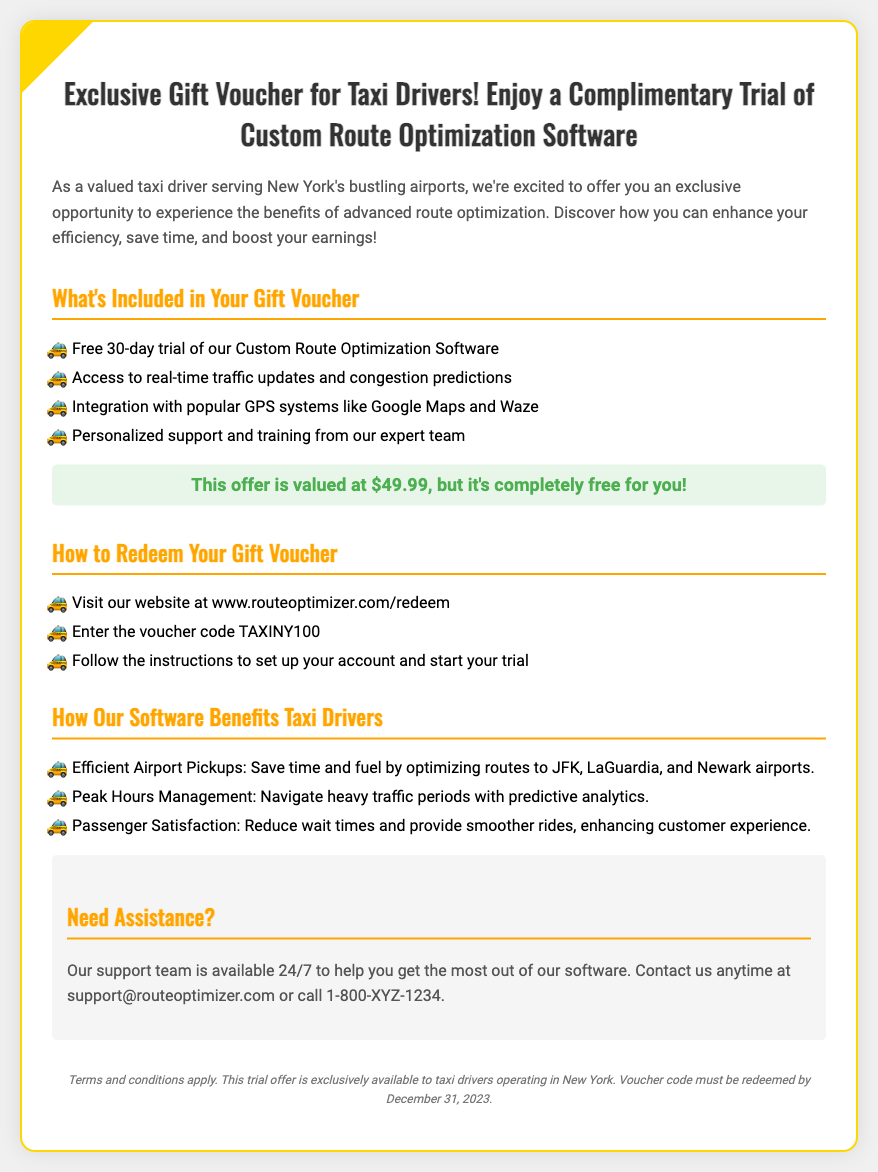What is the value of the voucher? The document states that the offer is valued at $49.99.
Answer: $49.99 How long is the trial period for the software? The document mentions a free 30-day trial included in the voucher.
Answer: 30-day What voucher code should be used for redemption? The document specifies the voucher code as TAXINY100.
Answer: TAXINY100 What is the website to redeem the voucher? It is mentioned in the document that the website is www.routeoptimizer.com/redeem.
Answer: www.routeoptimizer.com/redeem What type of support is provided during the trial? The document states that personalized support and training from the expert team is included.
Answer: Personalized support What are the operating airports mentioned in the benefits section? The document lists JFK, LaGuardia, and Newark airports for efficient pickups.
Answer: JFK, LaGuardia, Newark What can the software help with during peak hours? It is noted that it helps navigate heavy traffic periods with predictive analytics.
Answer: Predictive analytics When must the voucher code be redeemed by? The document specifies the redemption deadline as December 31, 2023.
Answer: December 31, 2023 